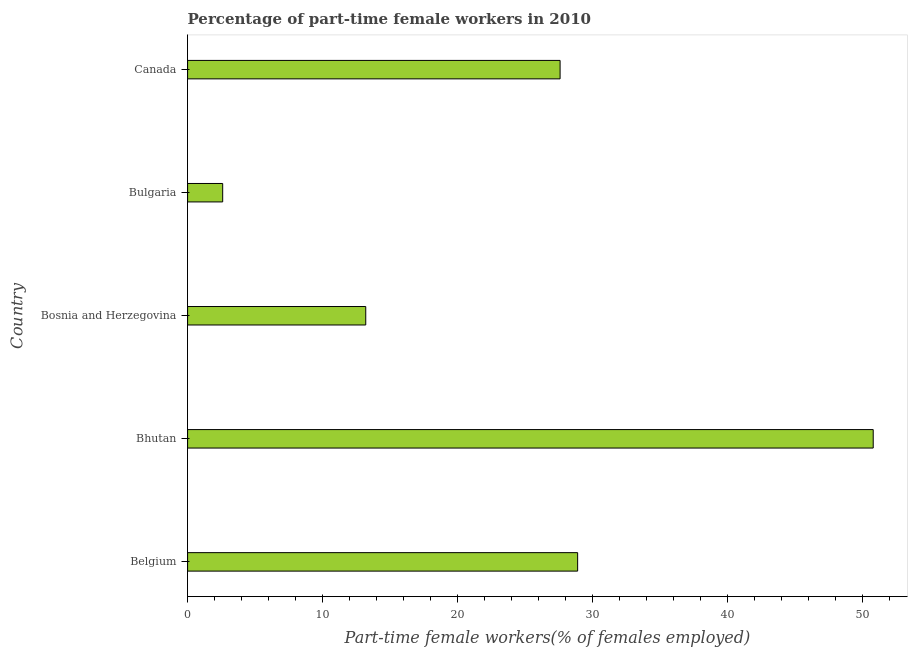Does the graph contain grids?
Keep it short and to the point. No. What is the title of the graph?
Offer a very short reply. Percentage of part-time female workers in 2010. What is the label or title of the X-axis?
Your response must be concise. Part-time female workers(% of females employed). What is the percentage of part-time female workers in Bhutan?
Keep it short and to the point. 50.8. Across all countries, what is the maximum percentage of part-time female workers?
Offer a very short reply. 50.8. Across all countries, what is the minimum percentage of part-time female workers?
Provide a succinct answer. 2.6. In which country was the percentage of part-time female workers maximum?
Keep it short and to the point. Bhutan. What is the sum of the percentage of part-time female workers?
Keep it short and to the point. 123.1. What is the difference between the percentage of part-time female workers in Bhutan and Bosnia and Herzegovina?
Keep it short and to the point. 37.6. What is the average percentage of part-time female workers per country?
Keep it short and to the point. 24.62. What is the median percentage of part-time female workers?
Keep it short and to the point. 27.6. What is the ratio of the percentage of part-time female workers in Belgium to that in Bhutan?
Provide a short and direct response. 0.57. What is the difference between the highest and the second highest percentage of part-time female workers?
Keep it short and to the point. 21.9. What is the difference between the highest and the lowest percentage of part-time female workers?
Offer a terse response. 48.2. What is the difference between two consecutive major ticks on the X-axis?
Your response must be concise. 10. What is the Part-time female workers(% of females employed) of Belgium?
Offer a very short reply. 28.9. What is the Part-time female workers(% of females employed) in Bhutan?
Provide a short and direct response. 50.8. What is the Part-time female workers(% of females employed) in Bosnia and Herzegovina?
Keep it short and to the point. 13.2. What is the Part-time female workers(% of females employed) of Bulgaria?
Your response must be concise. 2.6. What is the Part-time female workers(% of females employed) in Canada?
Your answer should be compact. 27.6. What is the difference between the Part-time female workers(% of females employed) in Belgium and Bhutan?
Give a very brief answer. -21.9. What is the difference between the Part-time female workers(% of females employed) in Belgium and Bulgaria?
Your answer should be very brief. 26.3. What is the difference between the Part-time female workers(% of females employed) in Belgium and Canada?
Give a very brief answer. 1.3. What is the difference between the Part-time female workers(% of females employed) in Bhutan and Bosnia and Herzegovina?
Make the answer very short. 37.6. What is the difference between the Part-time female workers(% of females employed) in Bhutan and Bulgaria?
Make the answer very short. 48.2. What is the difference between the Part-time female workers(% of females employed) in Bhutan and Canada?
Offer a terse response. 23.2. What is the difference between the Part-time female workers(% of females employed) in Bosnia and Herzegovina and Bulgaria?
Offer a very short reply. 10.6. What is the difference between the Part-time female workers(% of females employed) in Bosnia and Herzegovina and Canada?
Offer a very short reply. -14.4. What is the ratio of the Part-time female workers(% of females employed) in Belgium to that in Bhutan?
Provide a short and direct response. 0.57. What is the ratio of the Part-time female workers(% of females employed) in Belgium to that in Bosnia and Herzegovina?
Give a very brief answer. 2.19. What is the ratio of the Part-time female workers(% of females employed) in Belgium to that in Bulgaria?
Your answer should be compact. 11.12. What is the ratio of the Part-time female workers(% of females employed) in Belgium to that in Canada?
Give a very brief answer. 1.05. What is the ratio of the Part-time female workers(% of females employed) in Bhutan to that in Bosnia and Herzegovina?
Make the answer very short. 3.85. What is the ratio of the Part-time female workers(% of females employed) in Bhutan to that in Bulgaria?
Your response must be concise. 19.54. What is the ratio of the Part-time female workers(% of females employed) in Bhutan to that in Canada?
Offer a very short reply. 1.84. What is the ratio of the Part-time female workers(% of females employed) in Bosnia and Herzegovina to that in Bulgaria?
Provide a succinct answer. 5.08. What is the ratio of the Part-time female workers(% of females employed) in Bosnia and Herzegovina to that in Canada?
Keep it short and to the point. 0.48. What is the ratio of the Part-time female workers(% of females employed) in Bulgaria to that in Canada?
Provide a succinct answer. 0.09. 